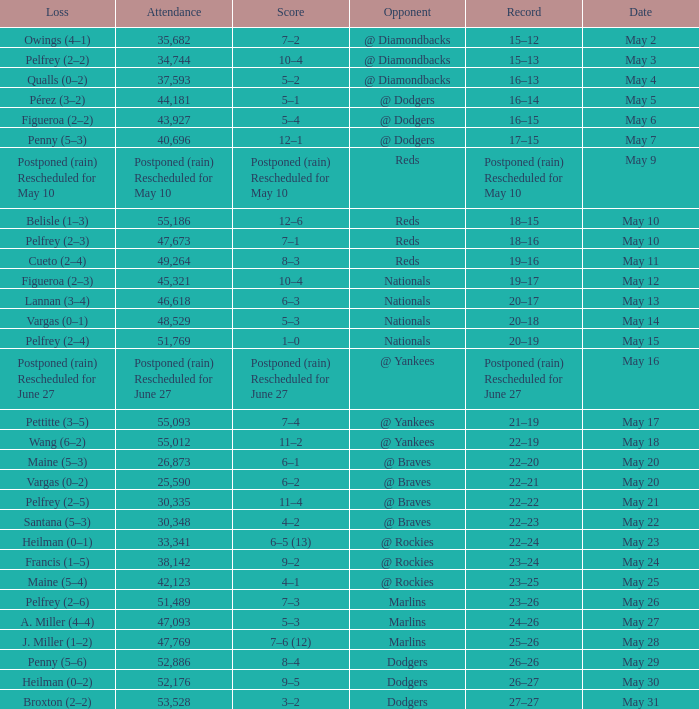Record of 22–20 involved what score? 6–1. 